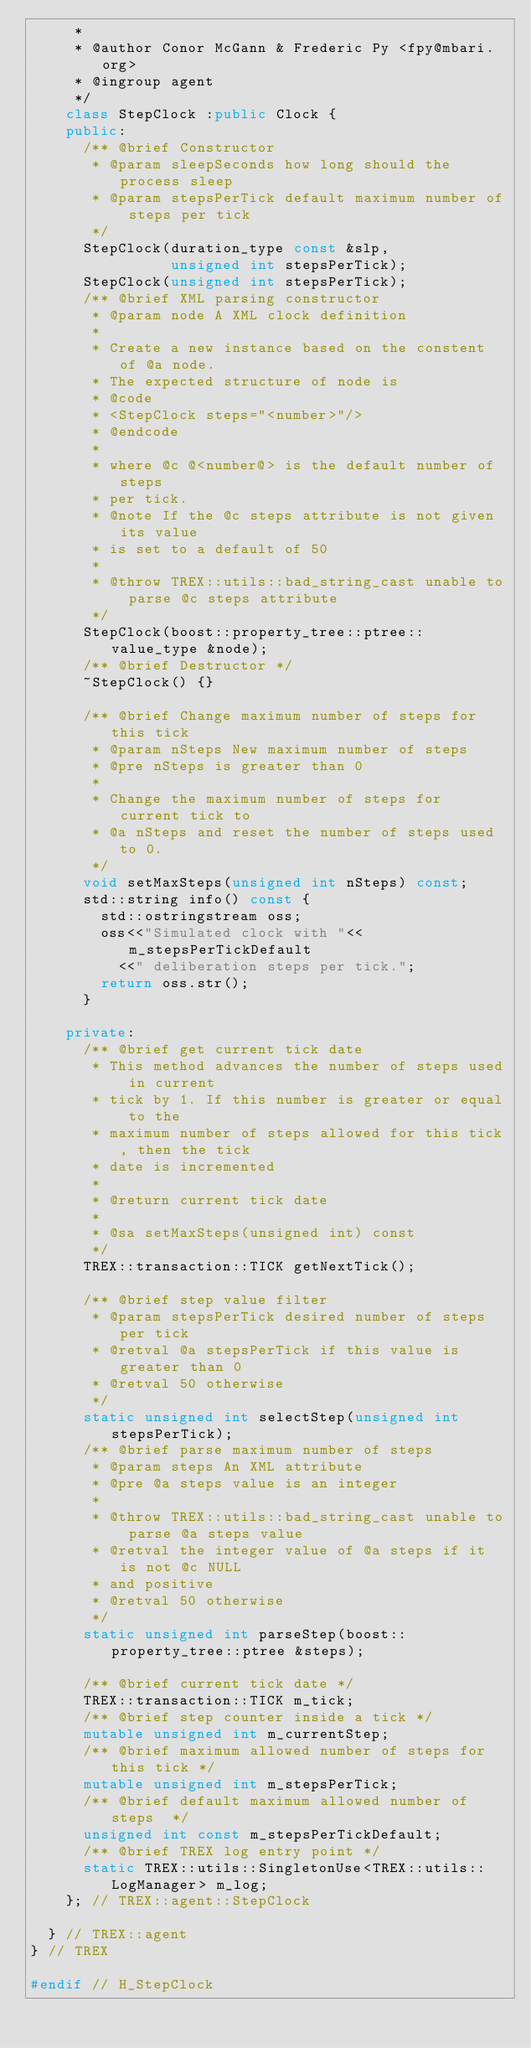<code> <loc_0><loc_0><loc_500><loc_500><_C++_>     *
     * @author Conor McGann & Frederic Py <fpy@mbari.org>
     * @ingroup agent
     */
    class StepClock :public Clock {
    public:
      /** @brief Constructor
       * @param sleepSeconds how long should the process sleep
       * @param stepsPerTick default maximum number of steps per tick
       */
      StepClock(duration_type const &slp, 
                unsigned int stepsPerTick);
      StepClock(unsigned int stepsPerTick);
      /** @brief XML parsing constructor
       * @param node A XML clock definition
       *
       * Create a new instance based on the constent of @a node.
       * The expected structure of node is 
       * @code
       * <StepClock steps="<number>"/>
       * @endcode
       *
       * where @c @<number@> is the default number of steps
       * per tick.
       * @note If the @c steps attribute is not given its value
       * is set to a default of 50
       *
       * @throw TREX::utils::bad_string_cast unable to parse @c steps attribute
       */
      StepClock(boost::property_tree::ptree::value_type &node);
      /** @brief Destructor */
      ~StepClock() {}

      /** @brief Change maximum number of steps for this tick
       * @param nSteps New maximum number of steps
       * @pre nSteps is greater than 0
       * 
       * Change the maximum number of steps for current tick to
       * @a nSteps and reset the number of steps used to 0.
       */
      void setMaxSteps(unsigned int nSteps) const;
      std::string info() const {
        std::ostringstream oss;
        oss<<"Simulated clock with "<<m_stepsPerTickDefault
          <<" deliberation steps per tick.";
        return oss.str();
      }

    private:
      /** @brief get current tick date
       * This method advances the number of steps used in current
       * tick by 1. If this number is greater or equal to the
       * maximum number of steps allowed for this tick, then the tick
       * date is incremented
       *
       * @return current tick date
       *
       * @sa setMaxSteps(unsigned int) const
       */
      TREX::transaction::TICK getNextTick();
      
      /** @brief step value filter
       * @param stepsPerTick desired number of steps per tick
       * @retval @a stepsPerTick if this value is greater than 0
       * @retval 50 otherwise
       */
      static unsigned int selectStep(unsigned int stepsPerTick);
      /** @brief parse maximum number of steps
       * @param steps An XML attribute
       * @pre @a steps value is an integer
       *
       * @throw TREX::utils::bad_string_cast unable to parse @a steps value
       * @retval the integer value of @a steps if it is not @c NULL
       * and positive
       * @retval 50 otherwise
       */
      static unsigned int parseStep(boost::property_tree::ptree &steps);

      /** @brief current tick date */
      TREX::transaction::TICK m_tick;
      /** @brief step counter inside a tick */
      mutable unsigned int m_currentStep;
      /** @brief maximum allowed number of steps for this tick */
      mutable unsigned int m_stepsPerTick;
      /** @brief default maximum allowed number of steps  */
      unsigned int const m_stepsPerTickDefault;
      /** @brief TREX log entry point */ 
      static TREX::utils::SingletonUse<TREX::utils::LogManager> m_log;
    }; // TREX::agent::StepClock

  } // TREX::agent 
} // TREX

#endif // H_StepClock
</code> 